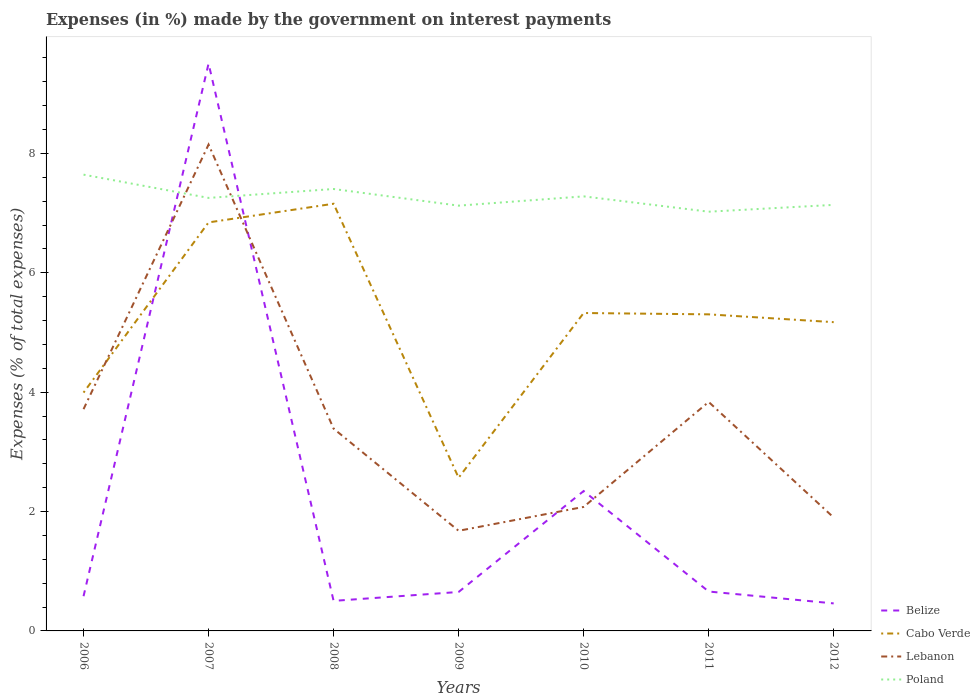Does the line corresponding to Poland intersect with the line corresponding to Cabo Verde?
Your answer should be compact. No. Across all years, what is the maximum percentage of expenses made by the government on interest payments in Poland?
Offer a terse response. 7.02. In which year was the percentage of expenses made by the government on interest payments in Lebanon maximum?
Ensure brevity in your answer.  2009. What is the total percentage of expenses made by the government on interest payments in Cabo Verde in the graph?
Offer a very short reply. 4.28. What is the difference between the highest and the second highest percentage of expenses made by the government on interest payments in Lebanon?
Make the answer very short. 6.47. What is the difference between the highest and the lowest percentage of expenses made by the government on interest payments in Belize?
Your answer should be very brief. 2. How many lines are there?
Provide a short and direct response. 4. Does the graph contain any zero values?
Your answer should be very brief. No. Does the graph contain grids?
Ensure brevity in your answer.  No. Where does the legend appear in the graph?
Offer a terse response. Bottom right. How many legend labels are there?
Provide a short and direct response. 4. How are the legend labels stacked?
Offer a very short reply. Vertical. What is the title of the graph?
Provide a succinct answer. Expenses (in %) made by the government on interest payments. Does "Turks and Caicos Islands" appear as one of the legend labels in the graph?
Offer a terse response. No. What is the label or title of the Y-axis?
Make the answer very short. Expenses (% of total expenses). What is the Expenses (% of total expenses) of Belize in 2006?
Ensure brevity in your answer.  0.58. What is the Expenses (% of total expenses) of Cabo Verde in 2006?
Ensure brevity in your answer.  3.99. What is the Expenses (% of total expenses) in Lebanon in 2006?
Offer a very short reply. 3.72. What is the Expenses (% of total expenses) in Poland in 2006?
Your response must be concise. 7.64. What is the Expenses (% of total expenses) of Belize in 2007?
Give a very brief answer. 9.51. What is the Expenses (% of total expenses) of Cabo Verde in 2007?
Give a very brief answer. 6.84. What is the Expenses (% of total expenses) of Lebanon in 2007?
Your answer should be very brief. 8.15. What is the Expenses (% of total expenses) in Poland in 2007?
Offer a very short reply. 7.26. What is the Expenses (% of total expenses) of Belize in 2008?
Make the answer very short. 0.5. What is the Expenses (% of total expenses) in Cabo Verde in 2008?
Your response must be concise. 7.16. What is the Expenses (% of total expenses) in Lebanon in 2008?
Offer a very short reply. 3.39. What is the Expenses (% of total expenses) in Poland in 2008?
Offer a very short reply. 7.4. What is the Expenses (% of total expenses) of Belize in 2009?
Make the answer very short. 0.65. What is the Expenses (% of total expenses) of Cabo Verde in 2009?
Keep it short and to the point. 2.57. What is the Expenses (% of total expenses) of Lebanon in 2009?
Ensure brevity in your answer.  1.68. What is the Expenses (% of total expenses) of Poland in 2009?
Offer a very short reply. 7.13. What is the Expenses (% of total expenses) of Belize in 2010?
Make the answer very short. 2.34. What is the Expenses (% of total expenses) in Cabo Verde in 2010?
Keep it short and to the point. 5.33. What is the Expenses (% of total expenses) in Lebanon in 2010?
Offer a very short reply. 2.08. What is the Expenses (% of total expenses) in Poland in 2010?
Offer a very short reply. 7.28. What is the Expenses (% of total expenses) of Belize in 2011?
Your answer should be compact. 0.66. What is the Expenses (% of total expenses) in Cabo Verde in 2011?
Your answer should be very brief. 5.3. What is the Expenses (% of total expenses) of Lebanon in 2011?
Make the answer very short. 3.84. What is the Expenses (% of total expenses) in Poland in 2011?
Ensure brevity in your answer.  7.02. What is the Expenses (% of total expenses) of Belize in 2012?
Your response must be concise. 0.46. What is the Expenses (% of total expenses) in Cabo Verde in 2012?
Offer a terse response. 5.17. What is the Expenses (% of total expenses) of Lebanon in 2012?
Ensure brevity in your answer.  1.9. What is the Expenses (% of total expenses) of Poland in 2012?
Your answer should be compact. 7.14. Across all years, what is the maximum Expenses (% of total expenses) of Belize?
Offer a terse response. 9.51. Across all years, what is the maximum Expenses (% of total expenses) in Cabo Verde?
Ensure brevity in your answer.  7.16. Across all years, what is the maximum Expenses (% of total expenses) of Lebanon?
Keep it short and to the point. 8.15. Across all years, what is the maximum Expenses (% of total expenses) in Poland?
Give a very brief answer. 7.64. Across all years, what is the minimum Expenses (% of total expenses) of Belize?
Provide a short and direct response. 0.46. Across all years, what is the minimum Expenses (% of total expenses) of Cabo Verde?
Offer a very short reply. 2.57. Across all years, what is the minimum Expenses (% of total expenses) of Lebanon?
Offer a terse response. 1.68. Across all years, what is the minimum Expenses (% of total expenses) of Poland?
Offer a terse response. 7.02. What is the total Expenses (% of total expenses) in Belize in the graph?
Your response must be concise. 14.71. What is the total Expenses (% of total expenses) of Cabo Verde in the graph?
Provide a succinct answer. 36.37. What is the total Expenses (% of total expenses) of Lebanon in the graph?
Keep it short and to the point. 24.74. What is the total Expenses (% of total expenses) in Poland in the graph?
Your response must be concise. 50.87. What is the difference between the Expenses (% of total expenses) in Belize in 2006 and that in 2007?
Give a very brief answer. -8.92. What is the difference between the Expenses (% of total expenses) in Cabo Verde in 2006 and that in 2007?
Make the answer very short. -2.85. What is the difference between the Expenses (% of total expenses) in Lebanon in 2006 and that in 2007?
Ensure brevity in your answer.  -4.43. What is the difference between the Expenses (% of total expenses) of Poland in 2006 and that in 2007?
Ensure brevity in your answer.  0.39. What is the difference between the Expenses (% of total expenses) of Belize in 2006 and that in 2008?
Your answer should be very brief. 0.08. What is the difference between the Expenses (% of total expenses) in Cabo Verde in 2006 and that in 2008?
Your answer should be very brief. -3.16. What is the difference between the Expenses (% of total expenses) in Lebanon in 2006 and that in 2008?
Your answer should be compact. 0.33. What is the difference between the Expenses (% of total expenses) in Poland in 2006 and that in 2008?
Keep it short and to the point. 0.24. What is the difference between the Expenses (% of total expenses) of Belize in 2006 and that in 2009?
Your answer should be very brief. -0.07. What is the difference between the Expenses (% of total expenses) of Cabo Verde in 2006 and that in 2009?
Your answer should be compact. 1.43. What is the difference between the Expenses (% of total expenses) of Lebanon in 2006 and that in 2009?
Provide a succinct answer. 2.04. What is the difference between the Expenses (% of total expenses) of Poland in 2006 and that in 2009?
Your response must be concise. 0.52. What is the difference between the Expenses (% of total expenses) of Belize in 2006 and that in 2010?
Make the answer very short. -1.76. What is the difference between the Expenses (% of total expenses) in Cabo Verde in 2006 and that in 2010?
Provide a succinct answer. -1.33. What is the difference between the Expenses (% of total expenses) in Lebanon in 2006 and that in 2010?
Provide a succinct answer. 1.64. What is the difference between the Expenses (% of total expenses) of Poland in 2006 and that in 2010?
Make the answer very short. 0.36. What is the difference between the Expenses (% of total expenses) of Belize in 2006 and that in 2011?
Provide a succinct answer. -0.08. What is the difference between the Expenses (% of total expenses) in Cabo Verde in 2006 and that in 2011?
Your answer should be compact. -1.31. What is the difference between the Expenses (% of total expenses) in Lebanon in 2006 and that in 2011?
Offer a terse response. -0.12. What is the difference between the Expenses (% of total expenses) in Poland in 2006 and that in 2011?
Offer a very short reply. 0.62. What is the difference between the Expenses (% of total expenses) of Belize in 2006 and that in 2012?
Offer a very short reply. 0.12. What is the difference between the Expenses (% of total expenses) of Cabo Verde in 2006 and that in 2012?
Your answer should be compact. -1.18. What is the difference between the Expenses (% of total expenses) in Lebanon in 2006 and that in 2012?
Your answer should be very brief. 1.82. What is the difference between the Expenses (% of total expenses) of Poland in 2006 and that in 2012?
Give a very brief answer. 0.51. What is the difference between the Expenses (% of total expenses) of Belize in 2007 and that in 2008?
Your answer should be very brief. 9. What is the difference between the Expenses (% of total expenses) of Cabo Verde in 2007 and that in 2008?
Make the answer very short. -0.31. What is the difference between the Expenses (% of total expenses) in Lebanon in 2007 and that in 2008?
Your answer should be very brief. 4.76. What is the difference between the Expenses (% of total expenses) of Poland in 2007 and that in 2008?
Give a very brief answer. -0.15. What is the difference between the Expenses (% of total expenses) in Belize in 2007 and that in 2009?
Give a very brief answer. 8.85. What is the difference between the Expenses (% of total expenses) in Cabo Verde in 2007 and that in 2009?
Offer a very short reply. 4.28. What is the difference between the Expenses (% of total expenses) of Lebanon in 2007 and that in 2009?
Provide a succinct answer. 6.47. What is the difference between the Expenses (% of total expenses) in Poland in 2007 and that in 2009?
Provide a succinct answer. 0.13. What is the difference between the Expenses (% of total expenses) in Belize in 2007 and that in 2010?
Make the answer very short. 7.16. What is the difference between the Expenses (% of total expenses) in Cabo Verde in 2007 and that in 2010?
Provide a short and direct response. 1.52. What is the difference between the Expenses (% of total expenses) in Lebanon in 2007 and that in 2010?
Offer a terse response. 6.07. What is the difference between the Expenses (% of total expenses) of Poland in 2007 and that in 2010?
Give a very brief answer. -0.03. What is the difference between the Expenses (% of total expenses) of Belize in 2007 and that in 2011?
Ensure brevity in your answer.  8.85. What is the difference between the Expenses (% of total expenses) of Cabo Verde in 2007 and that in 2011?
Ensure brevity in your answer.  1.54. What is the difference between the Expenses (% of total expenses) in Lebanon in 2007 and that in 2011?
Provide a succinct answer. 4.31. What is the difference between the Expenses (% of total expenses) in Poland in 2007 and that in 2011?
Your answer should be very brief. 0.23. What is the difference between the Expenses (% of total expenses) in Belize in 2007 and that in 2012?
Provide a short and direct response. 9.04. What is the difference between the Expenses (% of total expenses) in Cabo Verde in 2007 and that in 2012?
Your response must be concise. 1.67. What is the difference between the Expenses (% of total expenses) of Lebanon in 2007 and that in 2012?
Give a very brief answer. 6.25. What is the difference between the Expenses (% of total expenses) in Poland in 2007 and that in 2012?
Ensure brevity in your answer.  0.12. What is the difference between the Expenses (% of total expenses) of Belize in 2008 and that in 2009?
Give a very brief answer. -0.15. What is the difference between the Expenses (% of total expenses) of Cabo Verde in 2008 and that in 2009?
Your answer should be very brief. 4.59. What is the difference between the Expenses (% of total expenses) in Lebanon in 2008 and that in 2009?
Provide a short and direct response. 1.71. What is the difference between the Expenses (% of total expenses) of Poland in 2008 and that in 2009?
Offer a very short reply. 0.28. What is the difference between the Expenses (% of total expenses) of Belize in 2008 and that in 2010?
Give a very brief answer. -1.84. What is the difference between the Expenses (% of total expenses) of Cabo Verde in 2008 and that in 2010?
Provide a succinct answer. 1.83. What is the difference between the Expenses (% of total expenses) in Lebanon in 2008 and that in 2010?
Offer a terse response. 1.31. What is the difference between the Expenses (% of total expenses) of Poland in 2008 and that in 2010?
Give a very brief answer. 0.12. What is the difference between the Expenses (% of total expenses) in Belize in 2008 and that in 2011?
Provide a succinct answer. -0.16. What is the difference between the Expenses (% of total expenses) of Cabo Verde in 2008 and that in 2011?
Keep it short and to the point. 1.85. What is the difference between the Expenses (% of total expenses) of Lebanon in 2008 and that in 2011?
Give a very brief answer. -0.45. What is the difference between the Expenses (% of total expenses) of Poland in 2008 and that in 2011?
Make the answer very short. 0.38. What is the difference between the Expenses (% of total expenses) of Belize in 2008 and that in 2012?
Your answer should be compact. 0.04. What is the difference between the Expenses (% of total expenses) of Cabo Verde in 2008 and that in 2012?
Your answer should be compact. 1.98. What is the difference between the Expenses (% of total expenses) of Lebanon in 2008 and that in 2012?
Offer a terse response. 1.49. What is the difference between the Expenses (% of total expenses) in Poland in 2008 and that in 2012?
Give a very brief answer. 0.27. What is the difference between the Expenses (% of total expenses) of Belize in 2009 and that in 2010?
Make the answer very short. -1.69. What is the difference between the Expenses (% of total expenses) of Cabo Verde in 2009 and that in 2010?
Offer a terse response. -2.76. What is the difference between the Expenses (% of total expenses) in Lebanon in 2009 and that in 2010?
Offer a terse response. -0.4. What is the difference between the Expenses (% of total expenses) in Poland in 2009 and that in 2010?
Ensure brevity in your answer.  -0.16. What is the difference between the Expenses (% of total expenses) of Belize in 2009 and that in 2011?
Make the answer very short. -0.01. What is the difference between the Expenses (% of total expenses) of Cabo Verde in 2009 and that in 2011?
Give a very brief answer. -2.74. What is the difference between the Expenses (% of total expenses) of Lebanon in 2009 and that in 2011?
Your response must be concise. -2.16. What is the difference between the Expenses (% of total expenses) in Poland in 2009 and that in 2011?
Keep it short and to the point. 0.1. What is the difference between the Expenses (% of total expenses) in Belize in 2009 and that in 2012?
Make the answer very short. 0.19. What is the difference between the Expenses (% of total expenses) in Cabo Verde in 2009 and that in 2012?
Keep it short and to the point. -2.61. What is the difference between the Expenses (% of total expenses) in Lebanon in 2009 and that in 2012?
Offer a terse response. -0.22. What is the difference between the Expenses (% of total expenses) in Poland in 2009 and that in 2012?
Provide a succinct answer. -0.01. What is the difference between the Expenses (% of total expenses) in Belize in 2010 and that in 2011?
Your response must be concise. 1.68. What is the difference between the Expenses (% of total expenses) of Cabo Verde in 2010 and that in 2011?
Offer a terse response. 0.02. What is the difference between the Expenses (% of total expenses) of Lebanon in 2010 and that in 2011?
Keep it short and to the point. -1.76. What is the difference between the Expenses (% of total expenses) in Poland in 2010 and that in 2011?
Provide a succinct answer. 0.26. What is the difference between the Expenses (% of total expenses) in Belize in 2010 and that in 2012?
Your answer should be very brief. 1.88. What is the difference between the Expenses (% of total expenses) in Cabo Verde in 2010 and that in 2012?
Your answer should be compact. 0.15. What is the difference between the Expenses (% of total expenses) in Lebanon in 2010 and that in 2012?
Offer a very short reply. 0.18. What is the difference between the Expenses (% of total expenses) in Poland in 2010 and that in 2012?
Your response must be concise. 0.14. What is the difference between the Expenses (% of total expenses) of Belize in 2011 and that in 2012?
Offer a terse response. 0.2. What is the difference between the Expenses (% of total expenses) in Cabo Verde in 2011 and that in 2012?
Make the answer very short. 0.13. What is the difference between the Expenses (% of total expenses) of Lebanon in 2011 and that in 2012?
Your response must be concise. 1.94. What is the difference between the Expenses (% of total expenses) of Poland in 2011 and that in 2012?
Ensure brevity in your answer.  -0.11. What is the difference between the Expenses (% of total expenses) in Belize in 2006 and the Expenses (% of total expenses) in Cabo Verde in 2007?
Your answer should be very brief. -6.26. What is the difference between the Expenses (% of total expenses) in Belize in 2006 and the Expenses (% of total expenses) in Lebanon in 2007?
Provide a succinct answer. -7.57. What is the difference between the Expenses (% of total expenses) in Belize in 2006 and the Expenses (% of total expenses) in Poland in 2007?
Your response must be concise. -6.67. What is the difference between the Expenses (% of total expenses) of Cabo Verde in 2006 and the Expenses (% of total expenses) of Lebanon in 2007?
Your response must be concise. -4.16. What is the difference between the Expenses (% of total expenses) in Cabo Verde in 2006 and the Expenses (% of total expenses) in Poland in 2007?
Offer a terse response. -3.26. What is the difference between the Expenses (% of total expenses) in Lebanon in 2006 and the Expenses (% of total expenses) in Poland in 2007?
Provide a short and direct response. -3.54. What is the difference between the Expenses (% of total expenses) of Belize in 2006 and the Expenses (% of total expenses) of Cabo Verde in 2008?
Ensure brevity in your answer.  -6.58. What is the difference between the Expenses (% of total expenses) of Belize in 2006 and the Expenses (% of total expenses) of Lebanon in 2008?
Your answer should be compact. -2.81. What is the difference between the Expenses (% of total expenses) of Belize in 2006 and the Expenses (% of total expenses) of Poland in 2008?
Your answer should be very brief. -6.82. What is the difference between the Expenses (% of total expenses) of Cabo Verde in 2006 and the Expenses (% of total expenses) of Lebanon in 2008?
Provide a short and direct response. 0.6. What is the difference between the Expenses (% of total expenses) in Cabo Verde in 2006 and the Expenses (% of total expenses) in Poland in 2008?
Make the answer very short. -3.41. What is the difference between the Expenses (% of total expenses) in Lebanon in 2006 and the Expenses (% of total expenses) in Poland in 2008?
Your answer should be very brief. -3.69. What is the difference between the Expenses (% of total expenses) of Belize in 2006 and the Expenses (% of total expenses) of Cabo Verde in 2009?
Provide a succinct answer. -1.98. What is the difference between the Expenses (% of total expenses) in Belize in 2006 and the Expenses (% of total expenses) in Lebanon in 2009?
Offer a very short reply. -1.1. What is the difference between the Expenses (% of total expenses) of Belize in 2006 and the Expenses (% of total expenses) of Poland in 2009?
Provide a succinct answer. -6.54. What is the difference between the Expenses (% of total expenses) of Cabo Verde in 2006 and the Expenses (% of total expenses) of Lebanon in 2009?
Ensure brevity in your answer.  2.32. What is the difference between the Expenses (% of total expenses) of Cabo Verde in 2006 and the Expenses (% of total expenses) of Poland in 2009?
Your answer should be compact. -3.13. What is the difference between the Expenses (% of total expenses) in Lebanon in 2006 and the Expenses (% of total expenses) in Poland in 2009?
Your answer should be compact. -3.41. What is the difference between the Expenses (% of total expenses) of Belize in 2006 and the Expenses (% of total expenses) of Cabo Verde in 2010?
Make the answer very short. -4.74. What is the difference between the Expenses (% of total expenses) in Belize in 2006 and the Expenses (% of total expenses) in Lebanon in 2010?
Provide a succinct answer. -1.5. What is the difference between the Expenses (% of total expenses) in Belize in 2006 and the Expenses (% of total expenses) in Poland in 2010?
Provide a succinct answer. -6.7. What is the difference between the Expenses (% of total expenses) in Cabo Verde in 2006 and the Expenses (% of total expenses) in Lebanon in 2010?
Your answer should be very brief. 1.92. What is the difference between the Expenses (% of total expenses) in Cabo Verde in 2006 and the Expenses (% of total expenses) in Poland in 2010?
Your answer should be compact. -3.29. What is the difference between the Expenses (% of total expenses) of Lebanon in 2006 and the Expenses (% of total expenses) of Poland in 2010?
Your response must be concise. -3.57. What is the difference between the Expenses (% of total expenses) in Belize in 2006 and the Expenses (% of total expenses) in Cabo Verde in 2011?
Your response must be concise. -4.72. What is the difference between the Expenses (% of total expenses) in Belize in 2006 and the Expenses (% of total expenses) in Lebanon in 2011?
Keep it short and to the point. -3.25. What is the difference between the Expenses (% of total expenses) in Belize in 2006 and the Expenses (% of total expenses) in Poland in 2011?
Provide a succinct answer. -6.44. What is the difference between the Expenses (% of total expenses) of Cabo Verde in 2006 and the Expenses (% of total expenses) of Lebanon in 2011?
Ensure brevity in your answer.  0.16. What is the difference between the Expenses (% of total expenses) in Cabo Verde in 2006 and the Expenses (% of total expenses) in Poland in 2011?
Provide a short and direct response. -3.03. What is the difference between the Expenses (% of total expenses) of Lebanon in 2006 and the Expenses (% of total expenses) of Poland in 2011?
Provide a short and direct response. -3.31. What is the difference between the Expenses (% of total expenses) in Belize in 2006 and the Expenses (% of total expenses) in Cabo Verde in 2012?
Offer a terse response. -4.59. What is the difference between the Expenses (% of total expenses) of Belize in 2006 and the Expenses (% of total expenses) of Lebanon in 2012?
Give a very brief answer. -1.32. What is the difference between the Expenses (% of total expenses) in Belize in 2006 and the Expenses (% of total expenses) in Poland in 2012?
Provide a short and direct response. -6.56. What is the difference between the Expenses (% of total expenses) in Cabo Verde in 2006 and the Expenses (% of total expenses) in Lebanon in 2012?
Your answer should be compact. 2.09. What is the difference between the Expenses (% of total expenses) in Cabo Verde in 2006 and the Expenses (% of total expenses) in Poland in 2012?
Your answer should be compact. -3.15. What is the difference between the Expenses (% of total expenses) in Lebanon in 2006 and the Expenses (% of total expenses) in Poland in 2012?
Provide a succinct answer. -3.42. What is the difference between the Expenses (% of total expenses) of Belize in 2007 and the Expenses (% of total expenses) of Cabo Verde in 2008?
Offer a very short reply. 2.35. What is the difference between the Expenses (% of total expenses) in Belize in 2007 and the Expenses (% of total expenses) in Lebanon in 2008?
Make the answer very short. 6.12. What is the difference between the Expenses (% of total expenses) of Belize in 2007 and the Expenses (% of total expenses) of Poland in 2008?
Offer a very short reply. 2.1. What is the difference between the Expenses (% of total expenses) in Cabo Verde in 2007 and the Expenses (% of total expenses) in Lebanon in 2008?
Offer a very short reply. 3.46. What is the difference between the Expenses (% of total expenses) of Cabo Verde in 2007 and the Expenses (% of total expenses) of Poland in 2008?
Provide a short and direct response. -0.56. What is the difference between the Expenses (% of total expenses) of Lebanon in 2007 and the Expenses (% of total expenses) of Poland in 2008?
Give a very brief answer. 0.74. What is the difference between the Expenses (% of total expenses) of Belize in 2007 and the Expenses (% of total expenses) of Cabo Verde in 2009?
Offer a very short reply. 6.94. What is the difference between the Expenses (% of total expenses) in Belize in 2007 and the Expenses (% of total expenses) in Lebanon in 2009?
Ensure brevity in your answer.  7.83. What is the difference between the Expenses (% of total expenses) of Belize in 2007 and the Expenses (% of total expenses) of Poland in 2009?
Your response must be concise. 2.38. What is the difference between the Expenses (% of total expenses) in Cabo Verde in 2007 and the Expenses (% of total expenses) in Lebanon in 2009?
Give a very brief answer. 5.17. What is the difference between the Expenses (% of total expenses) of Cabo Verde in 2007 and the Expenses (% of total expenses) of Poland in 2009?
Your answer should be compact. -0.28. What is the difference between the Expenses (% of total expenses) in Lebanon in 2007 and the Expenses (% of total expenses) in Poland in 2009?
Provide a succinct answer. 1.02. What is the difference between the Expenses (% of total expenses) of Belize in 2007 and the Expenses (% of total expenses) of Cabo Verde in 2010?
Give a very brief answer. 4.18. What is the difference between the Expenses (% of total expenses) of Belize in 2007 and the Expenses (% of total expenses) of Lebanon in 2010?
Make the answer very short. 7.43. What is the difference between the Expenses (% of total expenses) of Belize in 2007 and the Expenses (% of total expenses) of Poland in 2010?
Offer a very short reply. 2.23. What is the difference between the Expenses (% of total expenses) in Cabo Verde in 2007 and the Expenses (% of total expenses) in Lebanon in 2010?
Provide a succinct answer. 4.77. What is the difference between the Expenses (% of total expenses) of Cabo Verde in 2007 and the Expenses (% of total expenses) of Poland in 2010?
Your response must be concise. -0.44. What is the difference between the Expenses (% of total expenses) of Lebanon in 2007 and the Expenses (% of total expenses) of Poland in 2010?
Make the answer very short. 0.87. What is the difference between the Expenses (% of total expenses) of Belize in 2007 and the Expenses (% of total expenses) of Cabo Verde in 2011?
Provide a short and direct response. 4.2. What is the difference between the Expenses (% of total expenses) of Belize in 2007 and the Expenses (% of total expenses) of Lebanon in 2011?
Your answer should be compact. 5.67. What is the difference between the Expenses (% of total expenses) in Belize in 2007 and the Expenses (% of total expenses) in Poland in 2011?
Offer a terse response. 2.48. What is the difference between the Expenses (% of total expenses) of Cabo Verde in 2007 and the Expenses (% of total expenses) of Lebanon in 2011?
Provide a short and direct response. 3.01. What is the difference between the Expenses (% of total expenses) in Cabo Verde in 2007 and the Expenses (% of total expenses) in Poland in 2011?
Your answer should be compact. -0.18. What is the difference between the Expenses (% of total expenses) of Lebanon in 2007 and the Expenses (% of total expenses) of Poland in 2011?
Make the answer very short. 1.12. What is the difference between the Expenses (% of total expenses) in Belize in 2007 and the Expenses (% of total expenses) in Cabo Verde in 2012?
Your answer should be compact. 4.33. What is the difference between the Expenses (% of total expenses) in Belize in 2007 and the Expenses (% of total expenses) in Lebanon in 2012?
Keep it short and to the point. 7.61. What is the difference between the Expenses (% of total expenses) of Belize in 2007 and the Expenses (% of total expenses) of Poland in 2012?
Keep it short and to the point. 2.37. What is the difference between the Expenses (% of total expenses) of Cabo Verde in 2007 and the Expenses (% of total expenses) of Lebanon in 2012?
Keep it short and to the point. 4.95. What is the difference between the Expenses (% of total expenses) in Cabo Verde in 2007 and the Expenses (% of total expenses) in Poland in 2012?
Your response must be concise. -0.29. What is the difference between the Expenses (% of total expenses) in Lebanon in 2007 and the Expenses (% of total expenses) in Poland in 2012?
Offer a very short reply. 1.01. What is the difference between the Expenses (% of total expenses) in Belize in 2008 and the Expenses (% of total expenses) in Cabo Verde in 2009?
Give a very brief answer. -2.06. What is the difference between the Expenses (% of total expenses) of Belize in 2008 and the Expenses (% of total expenses) of Lebanon in 2009?
Ensure brevity in your answer.  -1.17. What is the difference between the Expenses (% of total expenses) of Belize in 2008 and the Expenses (% of total expenses) of Poland in 2009?
Your answer should be very brief. -6.62. What is the difference between the Expenses (% of total expenses) of Cabo Verde in 2008 and the Expenses (% of total expenses) of Lebanon in 2009?
Provide a succinct answer. 5.48. What is the difference between the Expenses (% of total expenses) of Cabo Verde in 2008 and the Expenses (% of total expenses) of Poland in 2009?
Give a very brief answer. 0.03. What is the difference between the Expenses (% of total expenses) in Lebanon in 2008 and the Expenses (% of total expenses) in Poland in 2009?
Keep it short and to the point. -3.74. What is the difference between the Expenses (% of total expenses) in Belize in 2008 and the Expenses (% of total expenses) in Cabo Verde in 2010?
Offer a terse response. -4.82. What is the difference between the Expenses (% of total expenses) of Belize in 2008 and the Expenses (% of total expenses) of Lebanon in 2010?
Offer a very short reply. -1.57. What is the difference between the Expenses (% of total expenses) of Belize in 2008 and the Expenses (% of total expenses) of Poland in 2010?
Keep it short and to the point. -6.78. What is the difference between the Expenses (% of total expenses) in Cabo Verde in 2008 and the Expenses (% of total expenses) in Lebanon in 2010?
Provide a succinct answer. 5.08. What is the difference between the Expenses (% of total expenses) in Cabo Verde in 2008 and the Expenses (% of total expenses) in Poland in 2010?
Your answer should be compact. -0.12. What is the difference between the Expenses (% of total expenses) of Lebanon in 2008 and the Expenses (% of total expenses) of Poland in 2010?
Provide a short and direct response. -3.89. What is the difference between the Expenses (% of total expenses) in Belize in 2008 and the Expenses (% of total expenses) in Cabo Verde in 2011?
Your answer should be very brief. -4.8. What is the difference between the Expenses (% of total expenses) of Belize in 2008 and the Expenses (% of total expenses) of Lebanon in 2011?
Ensure brevity in your answer.  -3.33. What is the difference between the Expenses (% of total expenses) in Belize in 2008 and the Expenses (% of total expenses) in Poland in 2011?
Keep it short and to the point. -6.52. What is the difference between the Expenses (% of total expenses) in Cabo Verde in 2008 and the Expenses (% of total expenses) in Lebanon in 2011?
Offer a very short reply. 3.32. What is the difference between the Expenses (% of total expenses) in Cabo Verde in 2008 and the Expenses (% of total expenses) in Poland in 2011?
Your answer should be compact. 0.13. What is the difference between the Expenses (% of total expenses) in Lebanon in 2008 and the Expenses (% of total expenses) in Poland in 2011?
Provide a short and direct response. -3.63. What is the difference between the Expenses (% of total expenses) in Belize in 2008 and the Expenses (% of total expenses) in Cabo Verde in 2012?
Offer a terse response. -4.67. What is the difference between the Expenses (% of total expenses) of Belize in 2008 and the Expenses (% of total expenses) of Lebanon in 2012?
Make the answer very short. -1.4. What is the difference between the Expenses (% of total expenses) of Belize in 2008 and the Expenses (% of total expenses) of Poland in 2012?
Offer a very short reply. -6.63. What is the difference between the Expenses (% of total expenses) in Cabo Verde in 2008 and the Expenses (% of total expenses) in Lebanon in 2012?
Give a very brief answer. 5.26. What is the difference between the Expenses (% of total expenses) of Cabo Verde in 2008 and the Expenses (% of total expenses) of Poland in 2012?
Offer a very short reply. 0.02. What is the difference between the Expenses (% of total expenses) in Lebanon in 2008 and the Expenses (% of total expenses) in Poland in 2012?
Your response must be concise. -3.75. What is the difference between the Expenses (% of total expenses) of Belize in 2009 and the Expenses (% of total expenses) of Cabo Verde in 2010?
Your answer should be very brief. -4.67. What is the difference between the Expenses (% of total expenses) of Belize in 2009 and the Expenses (% of total expenses) of Lebanon in 2010?
Offer a terse response. -1.43. What is the difference between the Expenses (% of total expenses) of Belize in 2009 and the Expenses (% of total expenses) of Poland in 2010?
Your response must be concise. -6.63. What is the difference between the Expenses (% of total expenses) in Cabo Verde in 2009 and the Expenses (% of total expenses) in Lebanon in 2010?
Your answer should be very brief. 0.49. What is the difference between the Expenses (% of total expenses) of Cabo Verde in 2009 and the Expenses (% of total expenses) of Poland in 2010?
Give a very brief answer. -4.71. What is the difference between the Expenses (% of total expenses) of Lebanon in 2009 and the Expenses (% of total expenses) of Poland in 2010?
Keep it short and to the point. -5.6. What is the difference between the Expenses (% of total expenses) of Belize in 2009 and the Expenses (% of total expenses) of Cabo Verde in 2011?
Your response must be concise. -4.65. What is the difference between the Expenses (% of total expenses) of Belize in 2009 and the Expenses (% of total expenses) of Lebanon in 2011?
Keep it short and to the point. -3.18. What is the difference between the Expenses (% of total expenses) in Belize in 2009 and the Expenses (% of total expenses) in Poland in 2011?
Your response must be concise. -6.37. What is the difference between the Expenses (% of total expenses) of Cabo Verde in 2009 and the Expenses (% of total expenses) of Lebanon in 2011?
Your answer should be very brief. -1.27. What is the difference between the Expenses (% of total expenses) of Cabo Verde in 2009 and the Expenses (% of total expenses) of Poland in 2011?
Your answer should be compact. -4.46. What is the difference between the Expenses (% of total expenses) in Lebanon in 2009 and the Expenses (% of total expenses) in Poland in 2011?
Your answer should be very brief. -5.35. What is the difference between the Expenses (% of total expenses) of Belize in 2009 and the Expenses (% of total expenses) of Cabo Verde in 2012?
Give a very brief answer. -4.52. What is the difference between the Expenses (% of total expenses) of Belize in 2009 and the Expenses (% of total expenses) of Lebanon in 2012?
Your answer should be very brief. -1.25. What is the difference between the Expenses (% of total expenses) in Belize in 2009 and the Expenses (% of total expenses) in Poland in 2012?
Provide a short and direct response. -6.49. What is the difference between the Expenses (% of total expenses) of Cabo Verde in 2009 and the Expenses (% of total expenses) of Lebanon in 2012?
Keep it short and to the point. 0.67. What is the difference between the Expenses (% of total expenses) in Cabo Verde in 2009 and the Expenses (% of total expenses) in Poland in 2012?
Provide a short and direct response. -4.57. What is the difference between the Expenses (% of total expenses) of Lebanon in 2009 and the Expenses (% of total expenses) of Poland in 2012?
Make the answer very short. -5.46. What is the difference between the Expenses (% of total expenses) of Belize in 2010 and the Expenses (% of total expenses) of Cabo Verde in 2011?
Give a very brief answer. -2.96. What is the difference between the Expenses (% of total expenses) in Belize in 2010 and the Expenses (% of total expenses) in Lebanon in 2011?
Your response must be concise. -1.49. What is the difference between the Expenses (% of total expenses) in Belize in 2010 and the Expenses (% of total expenses) in Poland in 2011?
Keep it short and to the point. -4.68. What is the difference between the Expenses (% of total expenses) in Cabo Verde in 2010 and the Expenses (% of total expenses) in Lebanon in 2011?
Your answer should be compact. 1.49. What is the difference between the Expenses (% of total expenses) in Cabo Verde in 2010 and the Expenses (% of total expenses) in Poland in 2011?
Your answer should be very brief. -1.7. What is the difference between the Expenses (% of total expenses) of Lebanon in 2010 and the Expenses (% of total expenses) of Poland in 2011?
Give a very brief answer. -4.95. What is the difference between the Expenses (% of total expenses) in Belize in 2010 and the Expenses (% of total expenses) in Cabo Verde in 2012?
Ensure brevity in your answer.  -2.83. What is the difference between the Expenses (% of total expenses) of Belize in 2010 and the Expenses (% of total expenses) of Lebanon in 2012?
Provide a short and direct response. 0.44. What is the difference between the Expenses (% of total expenses) in Belize in 2010 and the Expenses (% of total expenses) in Poland in 2012?
Offer a terse response. -4.79. What is the difference between the Expenses (% of total expenses) of Cabo Verde in 2010 and the Expenses (% of total expenses) of Lebanon in 2012?
Your response must be concise. 3.43. What is the difference between the Expenses (% of total expenses) of Cabo Verde in 2010 and the Expenses (% of total expenses) of Poland in 2012?
Your answer should be compact. -1.81. What is the difference between the Expenses (% of total expenses) of Lebanon in 2010 and the Expenses (% of total expenses) of Poland in 2012?
Provide a succinct answer. -5.06. What is the difference between the Expenses (% of total expenses) in Belize in 2011 and the Expenses (% of total expenses) in Cabo Verde in 2012?
Your answer should be very brief. -4.51. What is the difference between the Expenses (% of total expenses) in Belize in 2011 and the Expenses (% of total expenses) in Lebanon in 2012?
Provide a short and direct response. -1.24. What is the difference between the Expenses (% of total expenses) in Belize in 2011 and the Expenses (% of total expenses) in Poland in 2012?
Your answer should be very brief. -6.48. What is the difference between the Expenses (% of total expenses) of Cabo Verde in 2011 and the Expenses (% of total expenses) of Lebanon in 2012?
Ensure brevity in your answer.  3.4. What is the difference between the Expenses (% of total expenses) of Cabo Verde in 2011 and the Expenses (% of total expenses) of Poland in 2012?
Give a very brief answer. -1.83. What is the difference between the Expenses (% of total expenses) in Lebanon in 2011 and the Expenses (% of total expenses) in Poland in 2012?
Make the answer very short. -3.3. What is the average Expenses (% of total expenses) in Belize per year?
Ensure brevity in your answer.  2.1. What is the average Expenses (% of total expenses) of Cabo Verde per year?
Provide a short and direct response. 5.2. What is the average Expenses (% of total expenses) of Lebanon per year?
Provide a succinct answer. 3.54. What is the average Expenses (% of total expenses) in Poland per year?
Provide a short and direct response. 7.27. In the year 2006, what is the difference between the Expenses (% of total expenses) in Belize and Expenses (% of total expenses) in Cabo Verde?
Offer a very short reply. -3.41. In the year 2006, what is the difference between the Expenses (% of total expenses) in Belize and Expenses (% of total expenses) in Lebanon?
Give a very brief answer. -3.13. In the year 2006, what is the difference between the Expenses (% of total expenses) of Belize and Expenses (% of total expenses) of Poland?
Offer a very short reply. -7.06. In the year 2006, what is the difference between the Expenses (% of total expenses) in Cabo Verde and Expenses (% of total expenses) in Lebanon?
Offer a terse response. 0.28. In the year 2006, what is the difference between the Expenses (% of total expenses) in Cabo Verde and Expenses (% of total expenses) in Poland?
Your answer should be compact. -3.65. In the year 2006, what is the difference between the Expenses (% of total expenses) in Lebanon and Expenses (% of total expenses) in Poland?
Your answer should be very brief. -3.93. In the year 2007, what is the difference between the Expenses (% of total expenses) in Belize and Expenses (% of total expenses) in Cabo Verde?
Keep it short and to the point. 2.66. In the year 2007, what is the difference between the Expenses (% of total expenses) of Belize and Expenses (% of total expenses) of Lebanon?
Provide a succinct answer. 1.36. In the year 2007, what is the difference between the Expenses (% of total expenses) in Belize and Expenses (% of total expenses) in Poland?
Ensure brevity in your answer.  2.25. In the year 2007, what is the difference between the Expenses (% of total expenses) in Cabo Verde and Expenses (% of total expenses) in Lebanon?
Your response must be concise. -1.3. In the year 2007, what is the difference between the Expenses (% of total expenses) of Cabo Verde and Expenses (% of total expenses) of Poland?
Provide a short and direct response. -0.41. In the year 2007, what is the difference between the Expenses (% of total expenses) of Lebanon and Expenses (% of total expenses) of Poland?
Give a very brief answer. 0.89. In the year 2008, what is the difference between the Expenses (% of total expenses) of Belize and Expenses (% of total expenses) of Cabo Verde?
Offer a very short reply. -6.65. In the year 2008, what is the difference between the Expenses (% of total expenses) in Belize and Expenses (% of total expenses) in Lebanon?
Offer a terse response. -2.89. In the year 2008, what is the difference between the Expenses (% of total expenses) in Belize and Expenses (% of total expenses) in Poland?
Offer a terse response. -6.9. In the year 2008, what is the difference between the Expenses (% of total expenses) of Cabo Verde and Expenses (% of total expenses) of Lebanon?
Your answer should be very brief. 3.77. In the year 2008, what is the difference between the Expenses (% of total expenses) in Cabo Verde and Expenses (% of total expenses) in Poland?
Your response must be concise. -0.25. In the year 2008, what is the difference between the Expenses (% of total expenses) in Lebanon and Expenses (% of total expenses) in Poland?
Make the answer very short. -4.01. In the year 2009, what is the difference between the Expenses (% of total expenses) of Belize and Expenses (% of total expenses) of Cabo Verde?
Provide a short and direct response. -1.91. In the year 2009, what is the difference between the Expenses (% of total expenses) of Belize and Expenses (% of total expenses) of Lebanon?
Ensure brevity in your answer.  -1.03. In the year 2009, what is the difference between the Expenses (% of total expenses) in Belize and Expenses (% of total expenses) in Poland?
Ensure brevity in your answer.  -6.47. In the year 2009, what is the difference between the Expenses (% of total expenses) of Cabo Verde and Expenses (% of total expenses) of Lebanon?
Ensure brevity in your answer.  0.89. In the year 2009, what is the difference between the Expenses (% of total expenses) in Cabo Verde and Expenses (% of total expenses) in Poland?
Ensure brevity in your answer.  -4.56. In the year 2009, what is the difference between the Expenses (% of total expenses) of Lebanon and Expenses (% of total expenses) of Poland?
Offer a terse response. -5.45. In the year 2010, what is the difference between the Expenses (% of total expenses) in Belize and Expenses (% of total expenses) in Cabo Verde?
Provide a short and direct response. -2.98. In the year 2010, what is the difference between the Expenses (% of total expenses) of Belize and Expenses (% of total expenses) of Lebanon?
Your response must be concise. 0.27. In the year 2010, what is the difference between the Expenses (% of total expenses) of Belize and Expenses (% of total expenses) of Poland?
Offer a very short reply. -4.94. In the year 2010, what is the difference between the Expenses (% of total expenses) in Cabo Verde and Expenses (% of total expenses) in Lebanon?
Provide a short and direct response. 3.25. In the year 2010, what is the difference between the Expenses (% of total expenses) of Cabo Verde and Expenses (% of total expenses) of Poland?
Your response must be concise. -1.95. In the year 2010, what is the difference between the Expenses (% of total expenses) in Lebanon and Expenses (% of total expenses) in Poland?
Offer a terse response. -5.2. In the year 2011, what is the difference between the Expenses (% of total expenses) in Belize and Expenses (% of total expenses) in Cabo Verde?
Your response must be concise. -4.64. In the year 2011, what is the difference between the Expenses (% of total expenses) in Belize and Expenses (% of total expenses) in Lebanon?
Your response must be concise. -3.18. In the year 2011, what is the difference between the Expenses (% of total expenses) of Belize and Expenses (% of total expenses) of Poland?
Make the answer very short. -6.36. In the year 2011, what is the difference between the Expenses (% of total expenses) in Cabo Verde and Expenses (% of total expenses) in Lebanon?
Offer a terse response. 1.47. In the year 2011, what is the difference between the Expenses (% of total expenses) in Cabo Verde and Expenses (% of total expenses) in Poland?
Keep it short and to the point. -1.72. In the year 2011, what is the difference between the Expenses (% of total expenses) in Lebanon and Expenses (% of total expenses) in Poland?
Ensure brevity in your answer.  -3.19. In the year 2012, what is the difference between the Expenses (% of total expenses) of Belize and Expenses (% of total expenses) of Cabo Verde?
Give a very brief answer. -4.71. In the year 2012, what is the difference between the Expenses (% of total expenses) of Belize and Expenses (% of total expenses) of Lebanon?
Provide a short and direct response. -1.44. In the year 2012, what is the difference between the Expenses (% of total expenses) in Belize and Expenses (% of total expenses) in Poland?
Provide a short and direct response. -6.68. In the year 2012, what is the difference between the Expenses (% of total expenses) in Cabo Verde and Expenses (% of total expenses) in Lebanon?
Your answer should be very brief. 3.27. In the year 2012, what is the difference between the Expenses (% of total expenses) of Cabo Verde and Expenses (% of total expenses) of Poland?
Ensure brevity in your answer.  -1.97. In the year 2012, what is the difference between the Expenses (% of total expenses) of Lebanon and Expenses (% of total expenses) of Poland?
Provide a short and direct response. -5.24. What is the ratio of the Expenses (% of total expenses) of Belize in 2006 to that in 2007?
Keep it short and to the point. 0.06. What is the ratio of the Expenses (% of total expenses) of Cabo Verde in 2006 to that in 2007?
Ensure brevity in your answer.  0.58. What is the ratio of the Expenses (% of total expenses) in Lebanon in 2006 to that in 2007?
Offer a very short reply. 0.46. What is the ratio of the Expenses (% of total expenses) of Poland in 2006 to that in 2007?
Provide a short and direct response. 1.05. What is the ratio of the Expenses (% of total expenses) in Belize in 2006 to that in 2008?
Give a very brief answer. 1.16. What is the ratio of the Expenses (% of total expenses) in Cabo Verde in 2006 to that in 2008?
Provide a short and direct response. 0.56. What is the ratio of the Expenses (% of total expenses) in Lebanon in 2006 to that in 2008?
Offer a terse response. 1.1. What is the ratio of the Expenses (% of total expenses) in Poland in 2006 to that in 2008?
Give a very brief answer. 1.03. What is the ratio of the Expenses (% of total expenses) in Belize in 2006 to that in 2009?
Offer a terse response. 0.89. What is the ratio of the Expenses (% of total expenses) of Cabo Verde in 2006 to that in 2009?
Provide a succinct answer. 1.56. What is the ratio of the Expenses (% of total expenses) of Lebanon in 2006 to that in 2009?
Your answer should be very brief. 2.21. What is the ratio of the Expenses (% of total expenses) in Poland in 2006 to that in 2009?
Provide a short and direct response. 1.07. What is the ratio of the Expenses (% of total expenses) of Belize in 2006 to that in 2010?
Offer a very short reply. 0.25. What is the ratio of the Expenses (% of total expenses) of Cabo Verde in 2006 to that in 2010?
Offer a terse response. 0.75. What is the ratio of the Expenses (% of total expenses) of Lebanon in 2006 to that in 2010?
Ensure brevity in your answer.  1.79. What is the ratio of the Expenses (% of total expenses) in Belize in 2006 to that in 2011?
Provide a succinct answer. 0.88. What is the ratio of the Expenses (% of total expenses) in Cabo Verde in 2006 to that in 2011?
Ensure brevity in your answer.  0.75. What is the ratio of the Expenses (% of total expenses) of Lebanon in 2006 to that in 2011?
Your answer should be very brief. 0.97. What is the ratio of the Expenses (% of total expenses) of Poland in 2006 to that in 2011?
Your answer should be very brief. 1.09. What is the ratio of the Expenses (% of total expenses) of Belize in 2006 to that in 2012?
Ensure brevity in your answer.  1.26. What is the ratio of the Expenses (% of total expenses) of Cabo Verde in 2006 to that in 2012?
Your response must be concise. 0.77. What is the ratio of the Expenses (% of total expenses) in Lebanon in 2006 to that in 2012?
Offer a very short reply. 1.96. What is the ratio of the Expenses (% of total expenses) of Poland in 2006 to that in 2012?
Your answer should be very brief. 1.07. What is the ratio of the Expenses (% of total expenses) of Belize in 2007 to that in 2008?
Give a very brief answer. 18.88. What is the ratio of the Expenses (% of total expenses) of Cabo Verde in 2007 to that in 2008?
Make the answer very short. 0.96. What is the ratio of the Expenses (% of total expenses) in Lebanon in 2007 to that in 2008?
Your response must be concise. 2.4. What is the ratio of the Expenses (% of total expenses) in Poland in 2007 to that in 2008?
Offer a terse response. 0.98. What is the ratio of the Expenses (% of total expenses) in Belize in 2007 to that in 2009?
Your answer should be very brief. 14.57. What is the ratio of the Expenses (% of total expenses) of Cabo Verde in 2007 to that in 2009?
Offer a very short reply. 2.67. What is the ratio of the Expenses (% of total expenses) in Lebanon in 2007 to that in 2009?
Offer a very short reply. 4.86. What is the ratio of the Expenses (% of total expenses) in Poland in 2007 to that in 2009?
Your response must be concise. 1.02. What is the ratio of the Expenses (% of total expenses) in Belize in 2007 to that in 2010?
Your response must be concise. 4.06. What is the ratio of the Expenses (% of total expenses) in Cabo Verde in 2007 to that in 2010?
Your answer should be very brief. 1.28. What is the ratio of the Expenses (% of total expenses) of Lebanon in 2007 to that in 2010?
Provide a succinct answer. 3.92. What is the ratio of the Expenses (% of total expenses) of Belize in 2007 to that in 2011?
Your answer should be very brief. 14.4. What is the ratio of the Expenses (% of total expenses) in Cabo Verde in 2007 to that in 2011?
Keep it short and to the point. 1.29. What is the ratio of the Expenses (% of total expenses) of Lebanon in 2007 to that in 2011?
Your answer should be compact. 2.12. What is the ratio of the Expenses (% of total expenses) of Poland in 2007 to that in 2011?
Provide a succinct answer. 1.03. What is the ratio of the Expenses (% of total expenses) in Belize in 2007 to that in 2012?
Offer a very short reply. 20.62. What is the ratio of the Expenses (% of total expenses) in Cabo Verde in 2007 to that in 2012?
Your response must be concise. 1.32. What is the ratio of the Expenses (% of total expenses) of Lebanon in 2007 to that in 2012?
Offer a very short reply. 4.29. What is the ratio of the Expenses (% of total expenses) of Poland in 2007 to that in 2012?
Your answer should be very brief. 1.02. What is the ratio of the Expenses (% of total expenses) of Belize in 2008 to that in 2009?
Offer a terse response. 0.77. What is the ratio of the Expenses (% of total expenses) in Cabo Verde in 2008 to that in 2009?
Offer a very short reply. 2.79. What is the ratio of the Expenses (% of total expenses) in Lebanon in 2008 to that in 2009?
Keep it short and to the point. 2.02. What is the ratio of the Expenses (% of total expenses) of Poland in 2008 to that in 2009?
Ensure brevity in your answer.  1.04. What is the ratio of the Expenses (% of total expenses) of Belize in 2008 to that in 2010?
Provide a short and direct response. 0.21. What is the ratio of the Expenses (% of total expenses) of Cabo Verde in 2008 to that in 2010?
Give a very brief answer. 1.34. What is the ratio of the Expenses (% of total expenses) of Lebanon in 2008 to that in 2010?
Provide a succinct answer. 1.63. What is the ratio of the Expenses (% of total expenses) of Belize in 2008 to that in 2011?
Your answer should be compact. 0.76. What is the ratio of the Expenses (% of total expenses) in Cabo Verde in 2008 to that in 2011?
Make the answer very short. 1.35. What is the ratio of the Expenses (% of total expenses) of Lebanon in 2008 to that in 2011?
Offer a terse response. 0.88. What is the ratio of the Expenses (% of total expenses) of Poland in 2008 to that in 2011?
Your answer should be very brief. 1.05. What is the ratio of the Expenses (% of total expenses) of Belize in 2008 to that in 2012?
Your response must be concise. 1.09. What is the ratio of the Expenses (% of total expenses) of Cabo Verde in 2008 to that in 2012?
Provide a succinct answer. 1.38. What is the ratio of the Expenses (% of total expenses) in Lebanon in 2008 to that in 2012?
Make the answer very short. 1.78. What is the ratio of the Expenses (% of total expenses) of Poland in 2008 to that in 2012?
Provide a succinct answer. 1.04. What is the ratio of the Expenses (% of total expenses) of Belize in 2009 to that in 2010?
Your response must be concise. 0.28. What is the ratio of the Expenses (% of total expenses) of Cabo Verde in 2009 to that in 2010?
Your answer should be very brief. 0.48. What is the ratio of the Expenses (% of total expenses) of Lebanon in 2009 to that in 2010?
Your response must be concise. 0.81. What is the ratio of the Expenses (% of total expenses) in Poland in 2009 to that in 2010?
Keep it short and to the point. 0.98. What is the ratio of the Expenses (% of total expenses) of Belize in 2009 to that in 2011?
Offer a terse response. 0.99. What is the ratio of the Expenses (% of total expenses) of Cabo Verde in 2009 to that in 2011?
Your answer should be compact. 0.48. What is the ratio of the Expenses (% of total expenses) in Lebanon in 2009 to that in 2011?
Offer a terse response. 0.44. What is the ratio of the Expenses (% of total expenses) in Poland in 2009 to that in 2011?
Provide a succinct answer. 1.01. What is the ratio of the Expenses (% of total expenses) of Belize in 2009 to that in 2012?
Make the answer very short. 1.42. What is the ratio of the Expenses (% of total expenses) in Cabo Verde in 2009 to that in 2012?
Provide a succinct answer. 0.5. What is the ratio of the Expenses (% of total expenses) of Lebanon in 2009 to that in 2012?
Offer a very short reply. 0.88. What is the ratio of the Expenses (% of total expenses) in Poland in 2009 to that in 2012?
Offer a terse response. 1. What is the ratio of the Expenses (% of total expenses) in Belize in 2010 to that in 2011?
Offer a terse response. 3.55. What is the ratio of the Expenses (% of total expenses) of Cabo Verde in 2010 to that in 2011?
Offer a terse response. 1. What is the ratio of the Expenses (% of total expenses) in Lebanon in 2010 to that in 2011?
Make the answer very short. 0.54. What is the ratio of the Expenses (% of total expenses) of Poland in 2010 to that in 2011?
Your response must be concise. 1.04. What is the ratio of the Expenses (% of total expenses) of Belize in 2010 to that in 2012?
Offer a terse response. 5.08. What is the ratio of the Expenses (% of total expenses) in Cabo Verde in 2010 to that in 2012?
Your answer should be compact. 1.03. What is the ratio of the Expenses (% of total expenses) in Lebanon in 2010 to that in 2012?
Ensure brevity in your answer.  1.09. What is the ratio of the Expenses (% of total expenses) in Poland in 2010 to that in 2012?
Your answer should be very brief. 1.02. What is the ratio of the Expenses (% of total expenses) of Belize in 2011 to that in 2012?
Offer a very short reply. 1.43. What is the ratio of the Expenses (% of total expenses) in Cabo Verde in 2011 to that in 2012?
Keep it short and to the point. 1.03. What is the ratio of the Expenses (% of total expenses) of Lebanon in 2011 to that in 2012?
Your answer should be very brief. 2.02. What is the difference between the highest and the second highest Expenses (% of total expenses) in Belize?
Ensure brevity in your answer.  7.16. What is the difference between the highest and the second highest Expenses (% of total expenses) of Cabo Verde?
Your response must be concise. 0.31. What is the difference between the highest and the second highest Expenses (% of total expenses) of Lebanon?
Offer a very short reply. 4.31. What is the difference between the highest and the second highest Expenses (% of total expenses) of Poland?
Offer a terse response. 0.24. What is the difference between the highest and the lowest Expenses (% of total expenses) of Belize?
Give a very brief answer. 9.04. What is the difference between the highest and the lowest Expenses (% of total expenses) of Cabo Verde?
Your response must be concise. 4.59. What is the difference between the highest and the lowest Expenses (% of total expenses) in Lebanon?
Your answer should be very brief. 6.47. What is the difference between the highest and the lowest Expenses (% of total expenses) of Poland?
Ensure brevity in your answer.  0.62. 